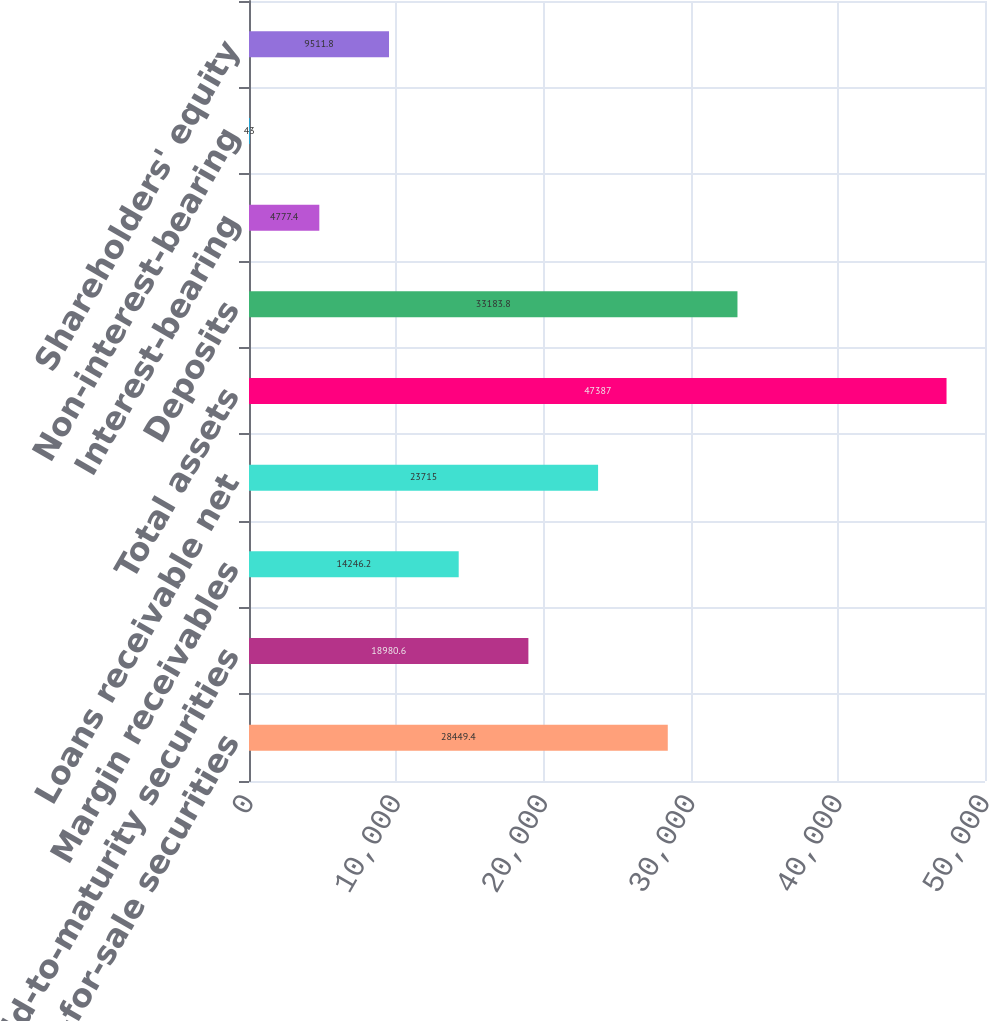<chart> <loc_0><loc_0><loc_500><loc_500><bar_chart><fcel>Available-for-sale securities<fcel>Held-to-maturity securities<fcel>Margin receivables<fcel>Loans receivable net<fcel>Total assets<fcel>Deposits<fcel>Interest-bearing<fcel>Non-interest-bearing<fcel>Shareholders' equity<nl><fcel>28449.4<fcel>18980.6<fcel>14246.2<fcel>23715<fcel>47387<fcel>33183.8<fcel>4777.4<fcel>43<fcel>9511.8<nl></chart> 